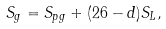Convert formula to latex. <formula><loc_0><loc_0><loc_500><loc_500>S _ { g } = S _ { p g } + ( 2 6 - d ) S _ { L } ,</formula> 